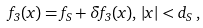Convert formula to latex. <formula><loc_0><loc_0><loc_500><loc_500>f _ { 3 } ( x ) = f _ { S } + \delta f _ { 3 } ( x ) , \, | x | < d _ { S } \, ,</formula> 